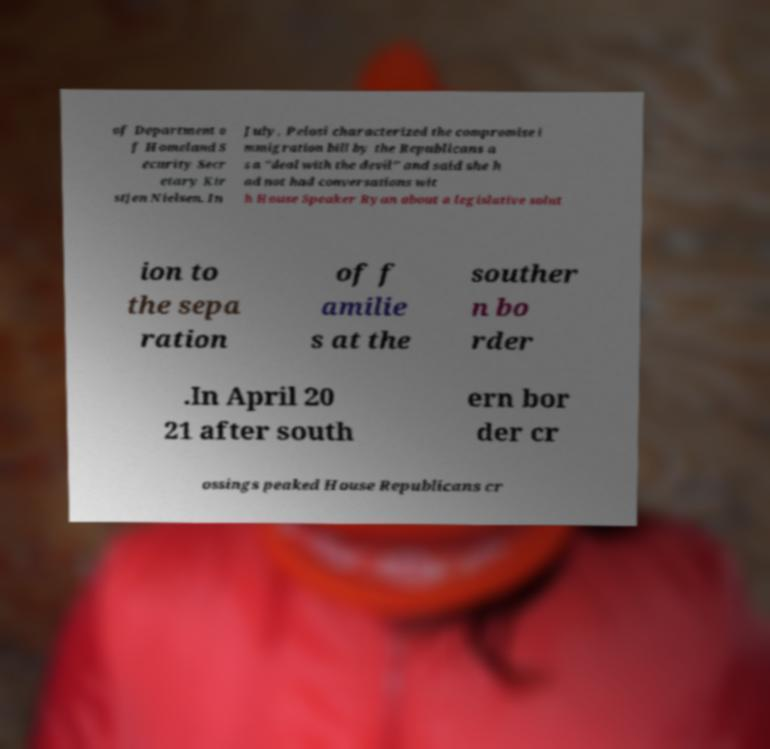Please identify and transcribe the text found in this image. of Department o f Homeland S ecurity Secr etary Kir stjen Nielsen. In July, Pelosi characterized the compromise i mmigration bill by the Republicans a s a "deal with the devil" and said she h ad not had conversations wit h House Speaker Ryan about a legislative solut ion to the sepa ration of f amilie s at the souther n bo rder .In April 20 21 after south ern bor der cr ossings peaked House Republicans cr 